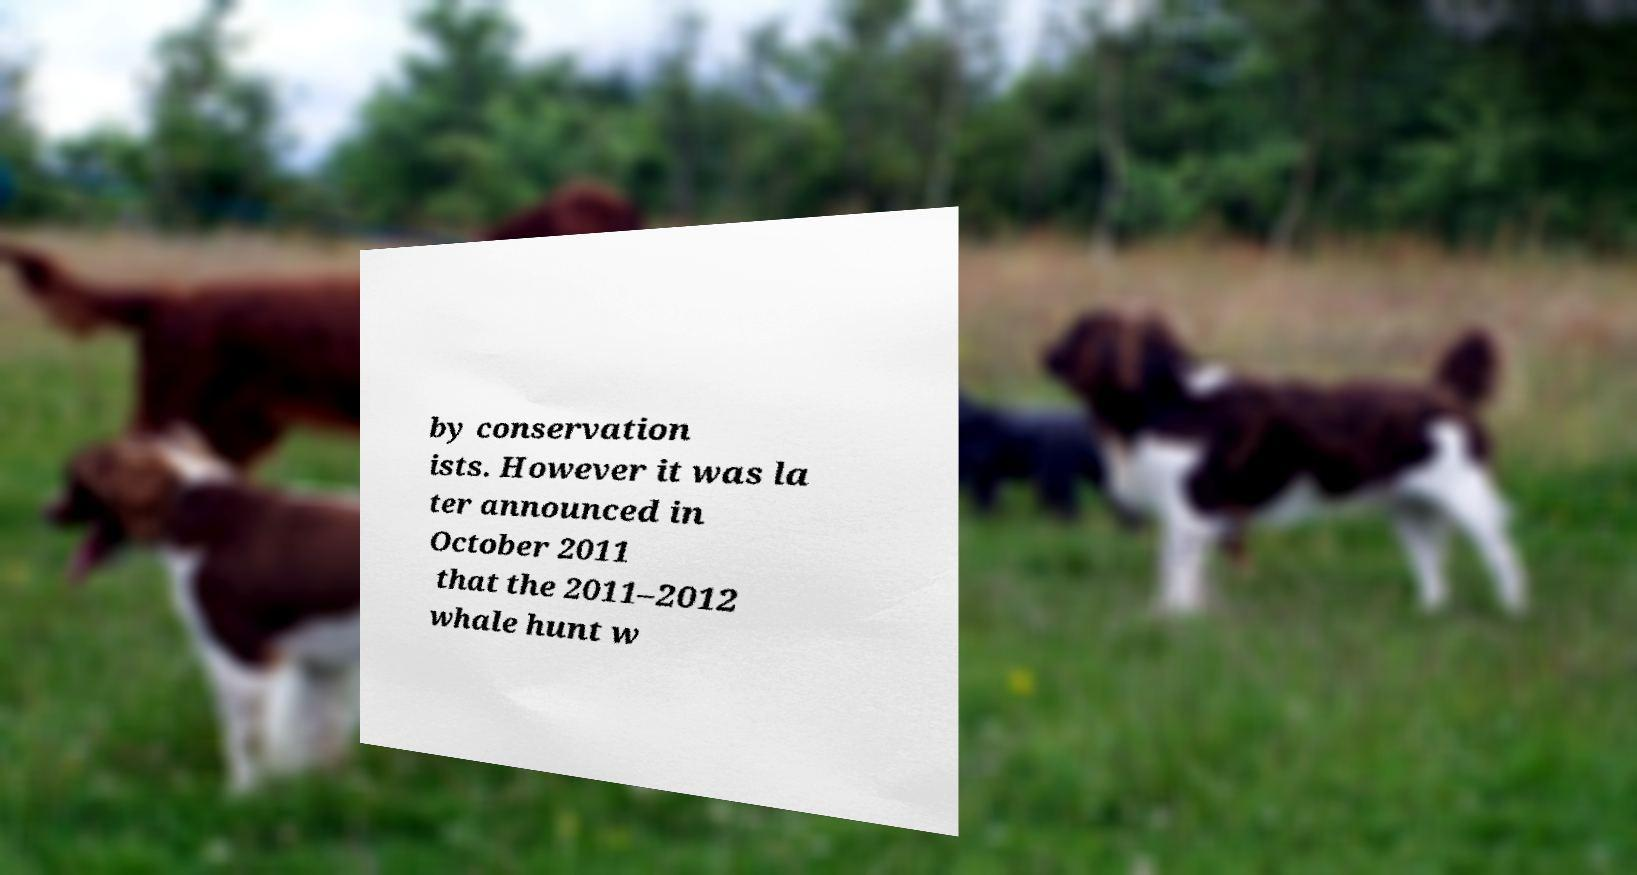Please identify and transcribe the text found in this image. by conservation ists. However it was la ter announced in October 2011 that the 2011–2012 whale hunt w 